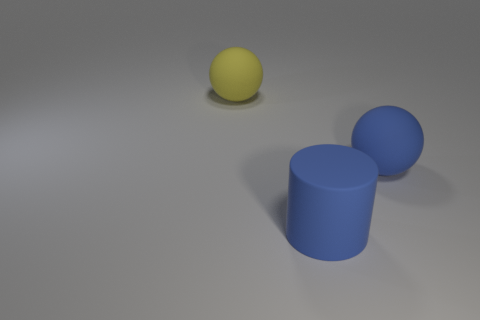Add 1 blue matte cylinders. How many objects exist? 4 Subtract all blue balls. How many balls are left? 1 Subtract 1 cylinders. How many cylinders are left? 0 Subtract all large spheres. Subtract all large gray rubber objects. How many objects are left? 1 Add 1 blue rubber objects. How many blue rubber objects are left? 3 Add 2 blue matte cylinders. How many blue matte cylinders exist? 3 Subtract 1 yellow spheres. How many objects are left? 2 Subtract all balls. How many objects are left? 1 Subtract all gray balls. Subtract all cyan cylinders. How many balls are left? 2 Subtract all red cylinders. How many yellow spheres are left? 1 